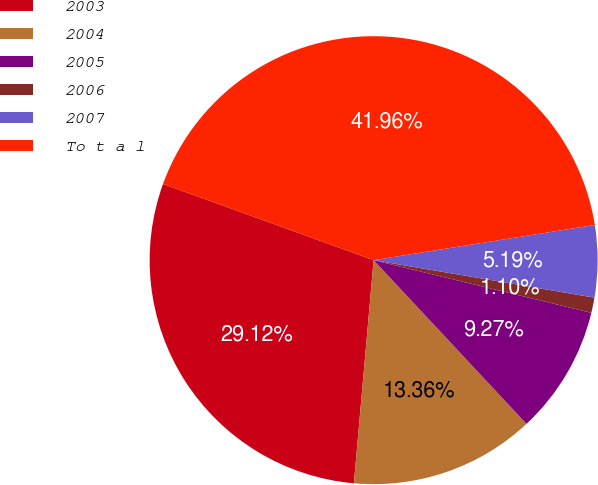Convert chart to OTSL. <chart><loc_0><loc_0><loc_500><loc_500><pie_chart><fcel>2003<fcel>2004<fcel>2005<fcel>2006<fcel>2007<fcel>To t a l<nl><fcel>29.12%<fcel>13.36%<fcel>9.27%<fcel>1.1%<fcel>5.19%<fcel>41.96%<nl></chart> 